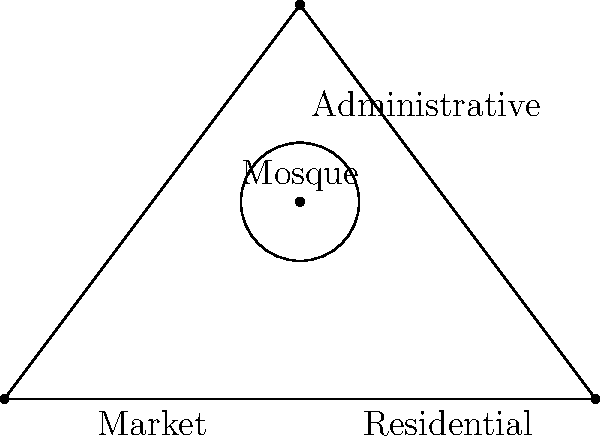In the Ottoman urban layout depicted above, what is the topological relationship between the mosque and the surrounding structures? To determine the topological relationship between the Ottoman-era mosque and the surrounding urban structures, we need to analyze the spatial arrangement:

1. The mosque is represented by the circle at point D, which is $(1.5,1)$ in the coordinate system.

2. The triangle ABC represents the overall urban area, divided into three main zones:
   - Market (left side)
   - Residential (right side)
   - Administrative (top)

3. The mosque's position relative to these structures:
   - It is located inside the triangle, indicating it's central to the urban layout.
   - It's positioned roughly at the centroid of the triangle, suggesting equal accessibility from all zones.

4. Topological analysis:
   - The mosque is adjacent to all three zones simultaneously.
   - It acts as a connecting point or node between the different urban functions.
   - The mosque maintains a central position without directly overlapping any specific zone.

5. This arrangement reflects the Ottoman urban planning principle of placing the mosque as the focal point of the community, serving both religious and social functions.

6. The topological relationship can be described as central and interconnecting, with the mosque acting as a hub that links the market, residential, and administrative areas.
Answer: Central and interconnecting hub 